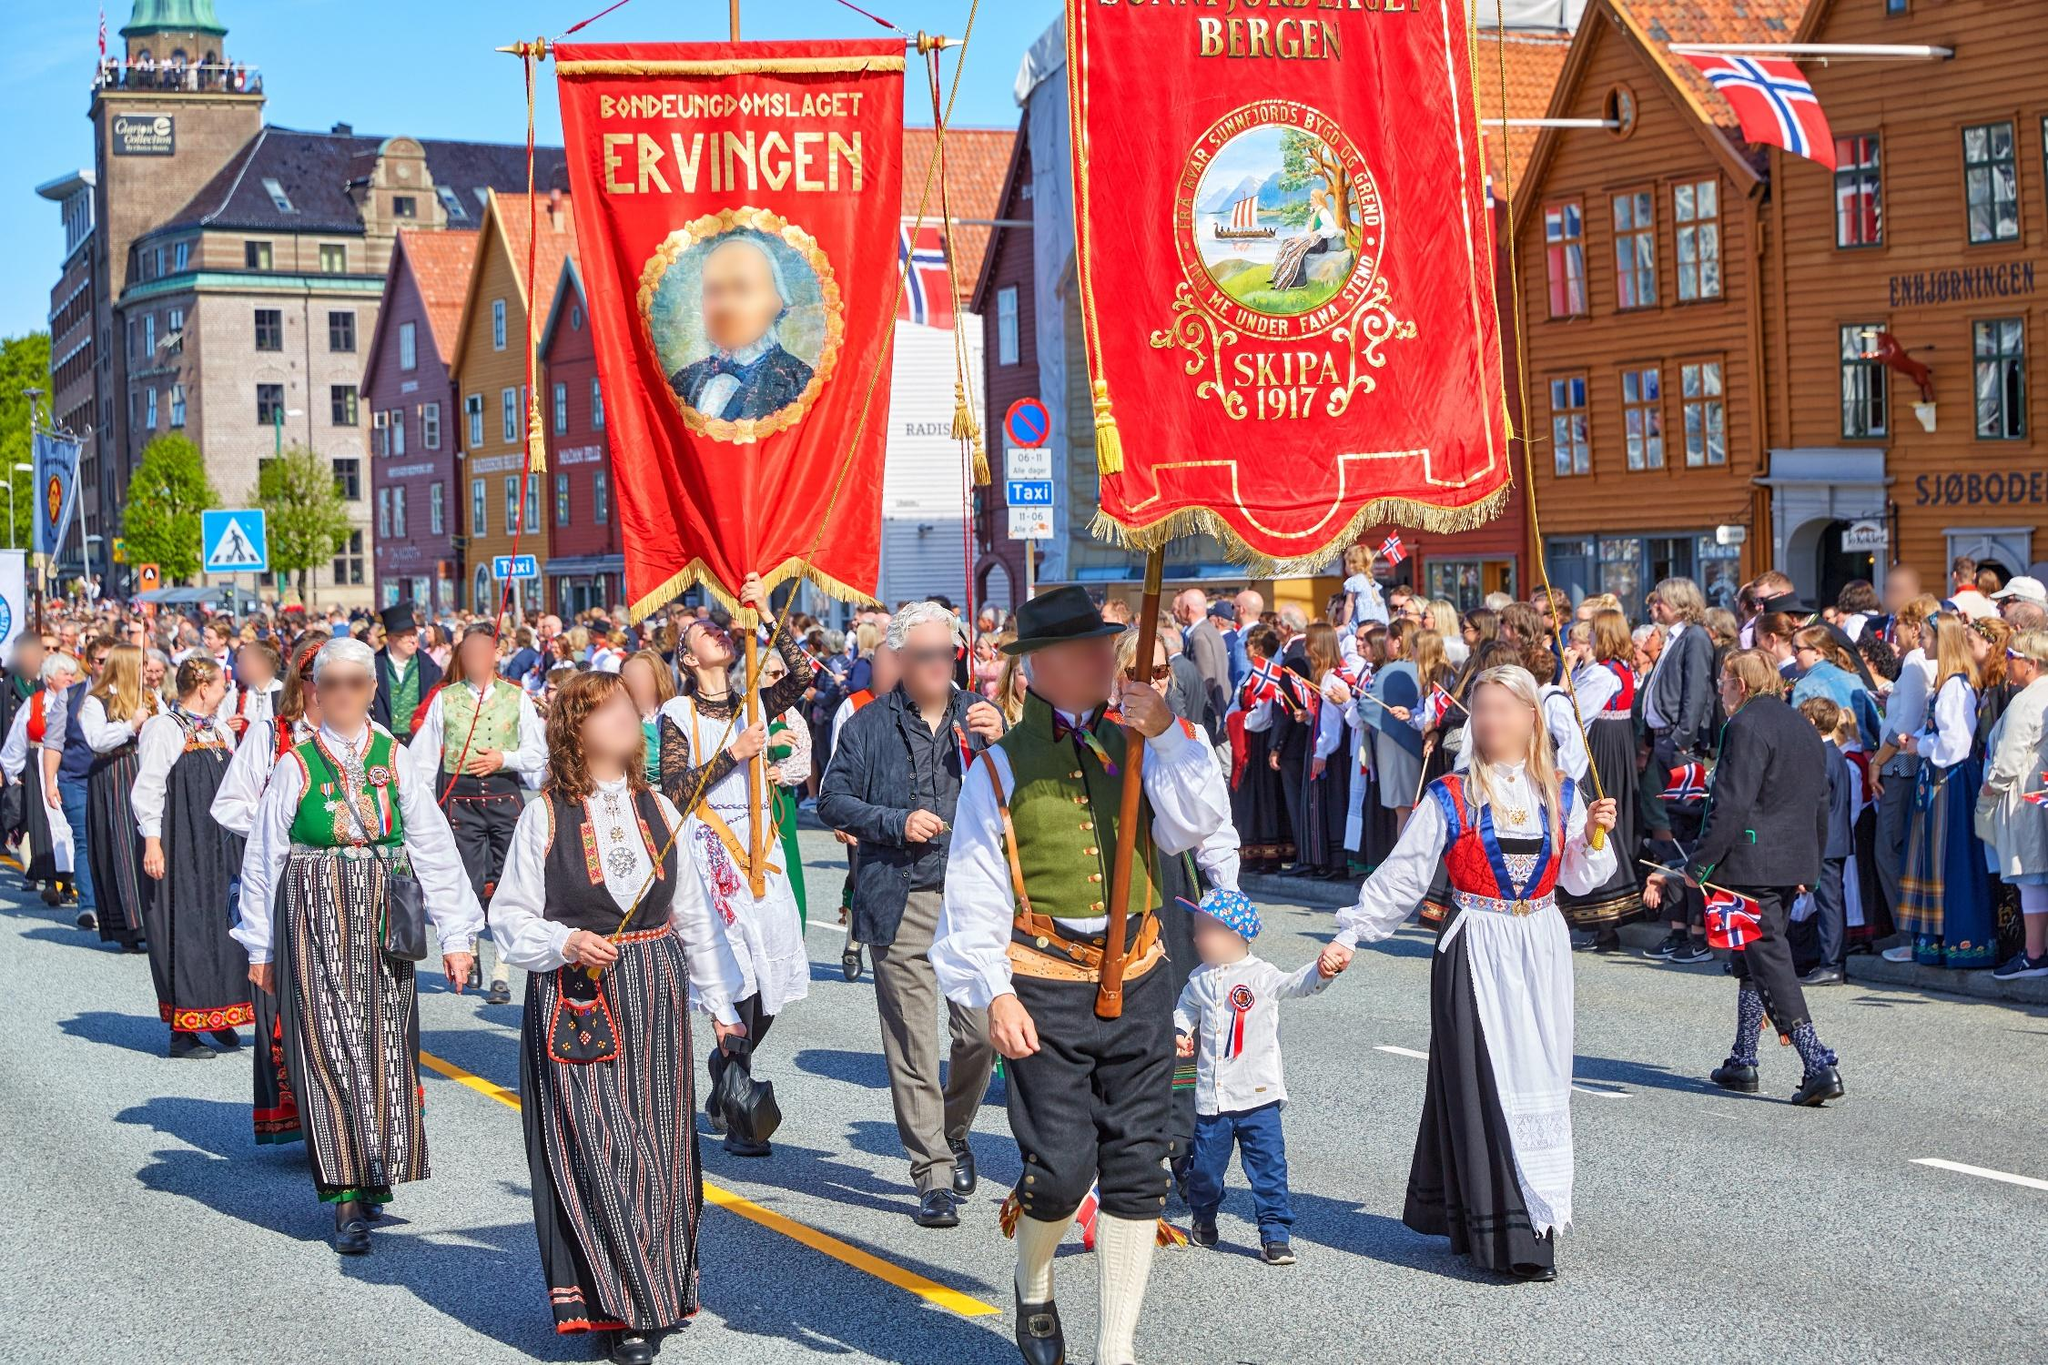Describe the atmosphere of the parade. The atmosphere of the parade is one of exuberant celebration and strong community spirit. There is a palpable sense of joy and pride as participants march down the street, dressed in colorful traditional attire. The vibrant banners and flags add a dynamic energy to the scene, while the clear blue sky enhances the overall brightness. Onlookers seem deeply engaged and enthusiastic, many waving flags and cheering. The combination of historical costumes, banners, and the festive crowd creates an atmosphere that is both celebratory and deeply rooted in cultural tradition. 